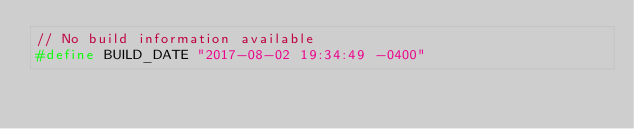Convert code to text. <code><loc_0><loc_0><loc_500><loc_500><_C_>// No build information available
#define BUILD_DATE "2017-08-02 19:34:49 -0400"
</code> 